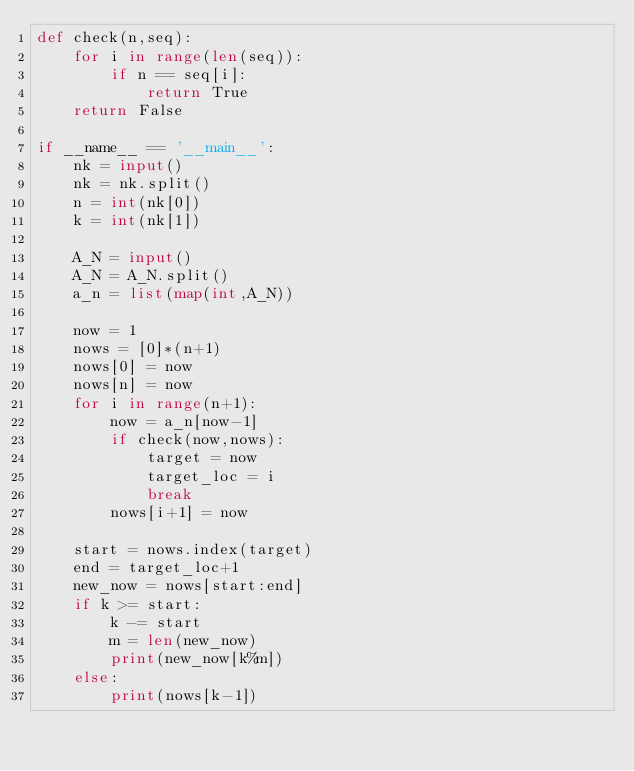<code> <loc_0><loc_0><loc_500><loc_500><_Python_>def check(n,seq):
    for i in range(len(seq)):
        if n == seq[i]:
            return True
    return False

if __name__ == '__main__':
    nk = input()
    nk = nk.split()
    n = int(nk[0])
    k = int(nk[1])

    A_N = input()
    A_N = A_N.split()
    a_n = list(map(int,A_N))

    now = 1
    nows = [0]*(n+1)
    nows[0] = now
    nows[n] = now
    for i in range(n+1):
        now = a_n[now-1]
        if check(now,nows):
            target = now
            target_loc = i
            break
        nows[i+1] = now

    start = nows.index(target) 
    end = target_loc+1
    new_now = nows[start:end]
    if k >= start:
        k -= start
        m = len(new_now)
        print(new_now[k%m])
    else:
        print(nows[k-1])</code> 